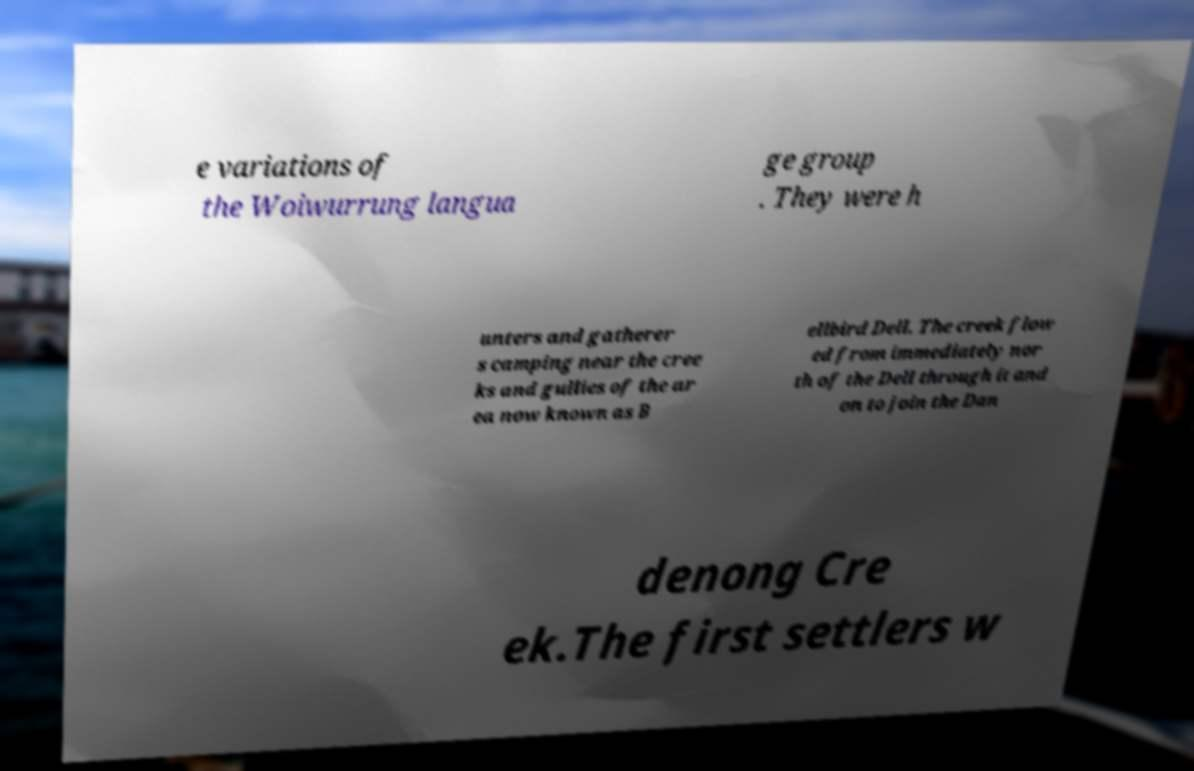Can you accurately transcribe the text from the provided image for me? e variations of the Woiwurrung langua ge group . They were h unters and gatherer s camping near the cree ks and gullies of the ar ea now known as B ellbird Dell. The creek flow ed from immediately nor th of the Dell through it and on to join the Dan denong Cre ek.The first settlers w 